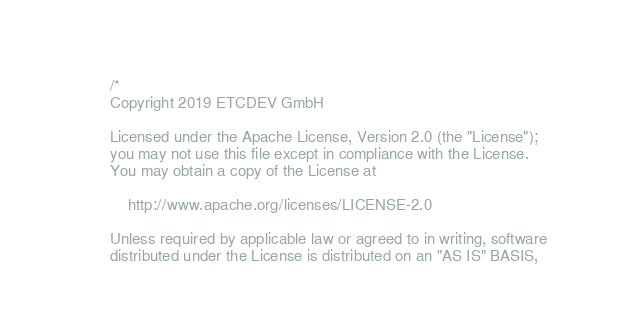Convert code to text. <code><loc_0><loc_0><loc_500><loc_500><_Rust_>/*
Copyright 2019 ETCDEV GmbH

Licensed under the Apache License, Version 2.0 (the "License");
you may not use this file except in compliance with the License.
You may obtain a copy of the License at

    http://www.apache.org/licenses/LICENSE-2.0

Unless required by applicable law or agreed to in writing, software
distributed under the License is distributed on an "AS IS" BASIS,</code> 